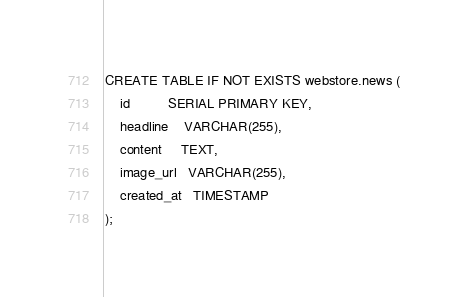Convert code to text. <code><loc_0><loc_0><loc_500><loc_500><_SQL_>CREATE TABLE IF NOT EXISTS webstore.news (
    id          SERIAL PRIMARY KEY,
    headline    VARCHAR(255),
    content     TEXT,
    image_url   VARCHAR(255),
    created_at   TIMESTAMP
);
</code> 